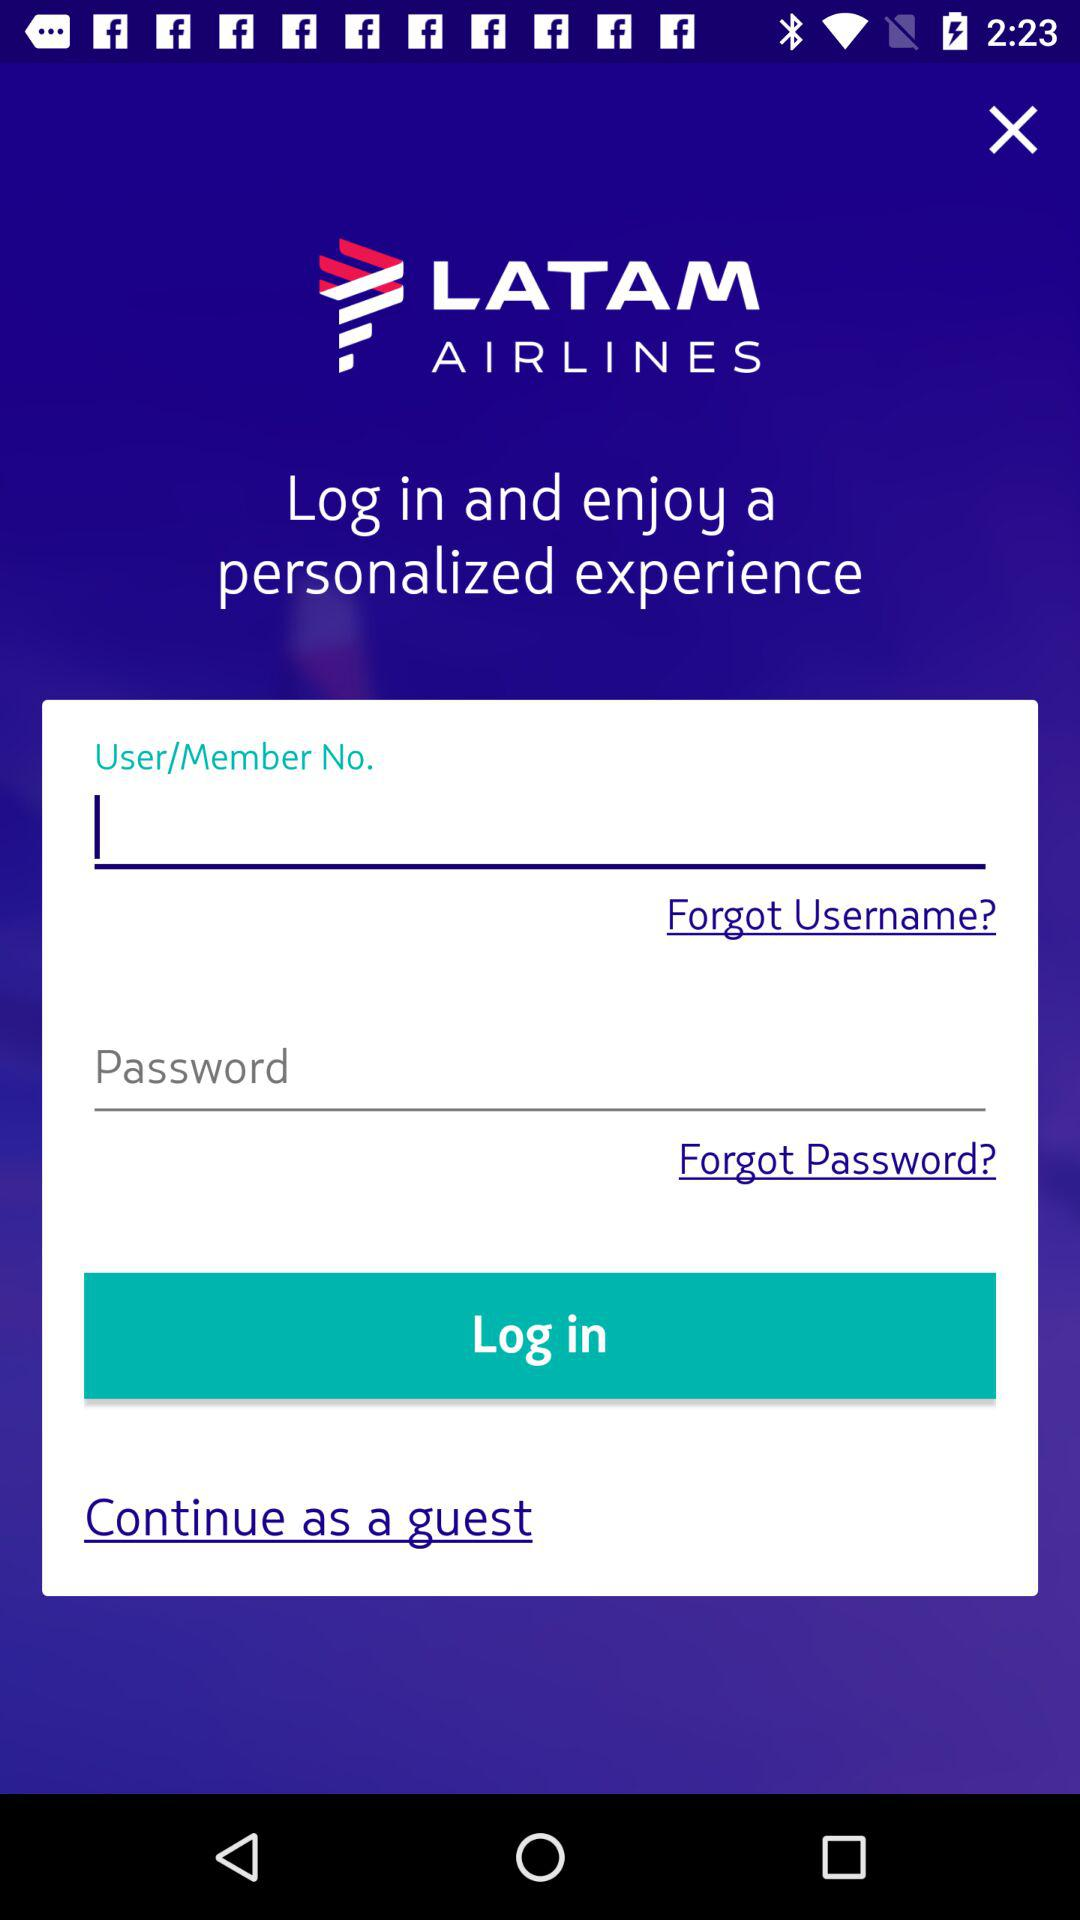What is the name of the application? The name of the application is "LATAM AIRLINES". 